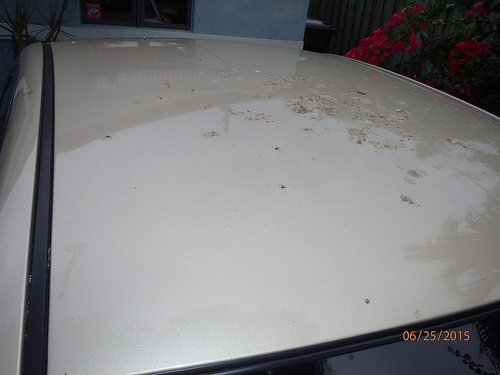<image>
Is the dirt next to the white car? No. The dirt is not positioned next to the white car. They are located in different areas of the scene. 